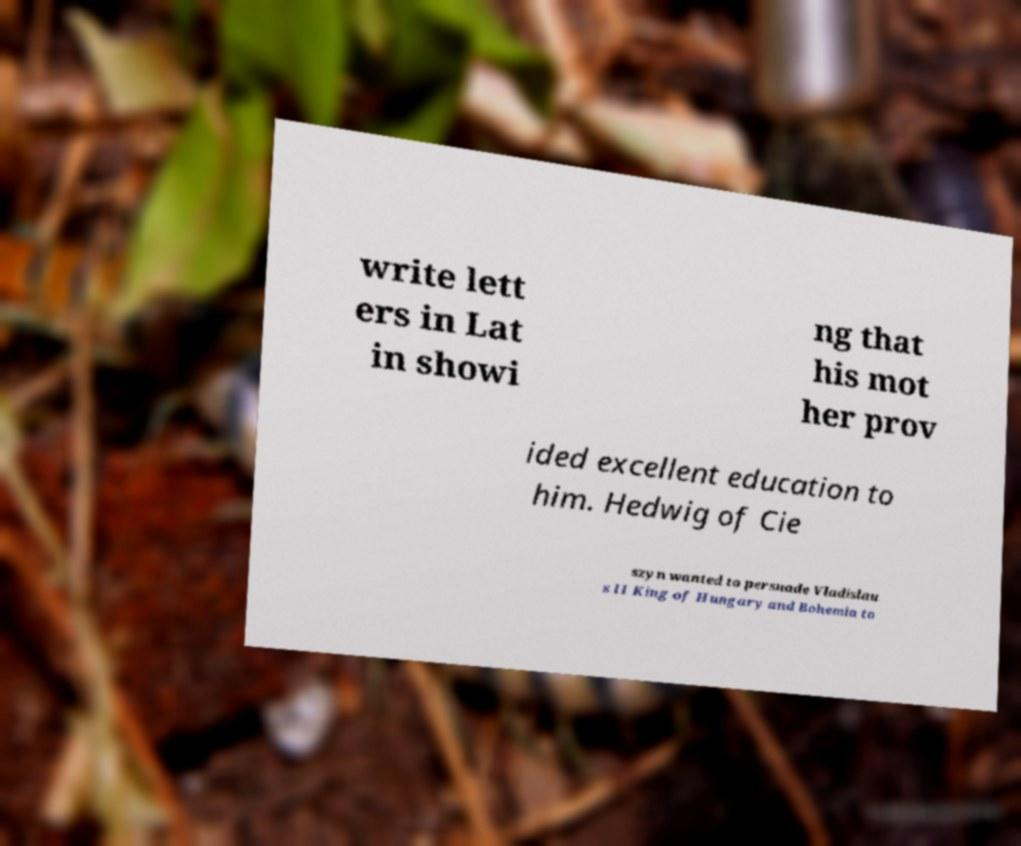There's text embedded in this image that I need extracted. Can you transcribe it verbatim? write lett ers in Lat in showi ng that his mot her prov ided excellent education to him. Hedwig of Cie szyn wanted to persuade Vladislau s II King of Hungary and Bohemia to 